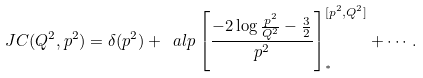<formula> <loc_0><loc_0><loc_500><loc_500>\ J C ( Q ^ { 2 } , p ^ { 2 } ) = \delta ( p ^ { 2 } ) + \ a l p \left [ \frac { - 2 \log \frac { p ^ { 2 } } { Q ^ { 2 } } - \frac { 3 } { 2 } } { p ^ { 2 } } \right ] _ { ^ { * } } ^ { [ p ^ { 2 } , Q ^ { 2 } ] } + \cdots .</formula> 